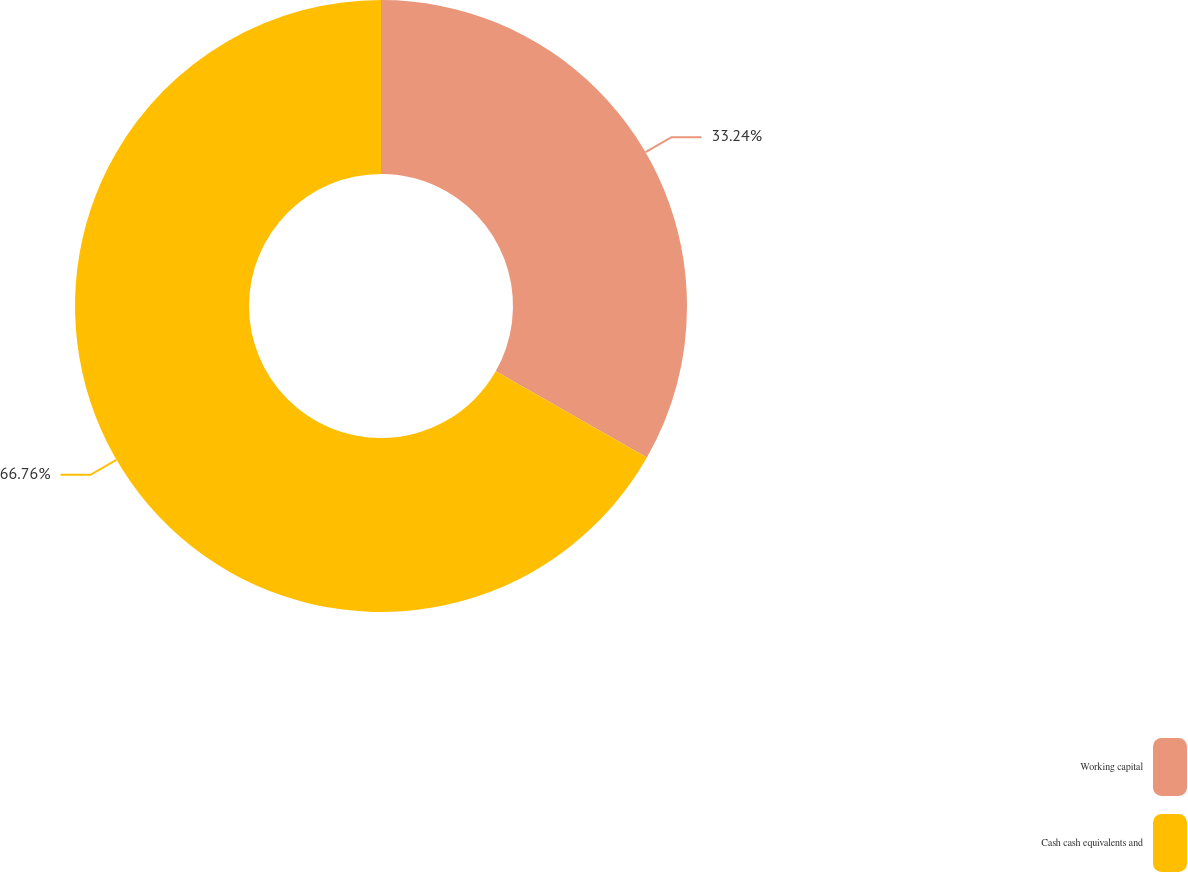Convert chart. <chart><loc_0><loc_0><loc_500><loc_500><pie_chart><fcel>Working capital<fcel>Cash cash equivalents and<nl><fcel>33.24%<fcel>66.76%<nl></chart> 